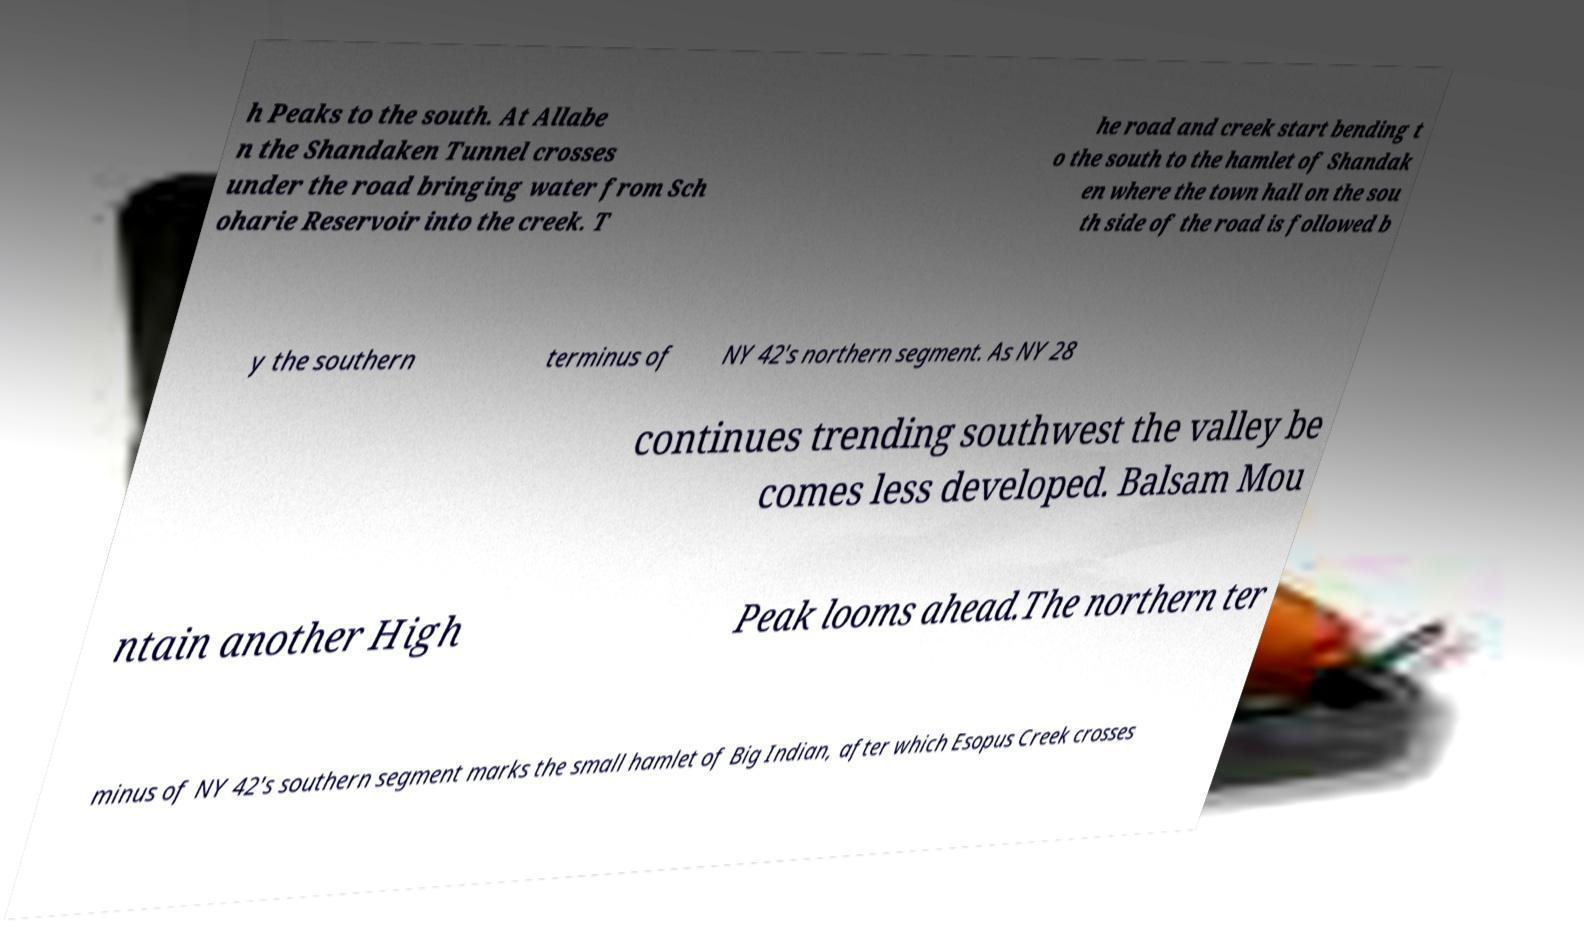Please read and relay the text visible in this image. What does it say? h Peaks to the south. At Allabe n the Shandaken Tunnel crosses under the road bringing water from Sch oharie Reservoir into the creek. T he road and creek start bending t o the south to the hamlet of Shandak en where the town hall on the sou th side of the road is followed b y the southern terminus of NY 42's northern segment. As NY 28 continues trending southwest the valley be comes less developed. Balsam Mou ntain another High Peak looms ahead.The northern ter minus of NY 42's southern segment marks the small hamlet of Big Indian, after which Esopus Creek crosses 